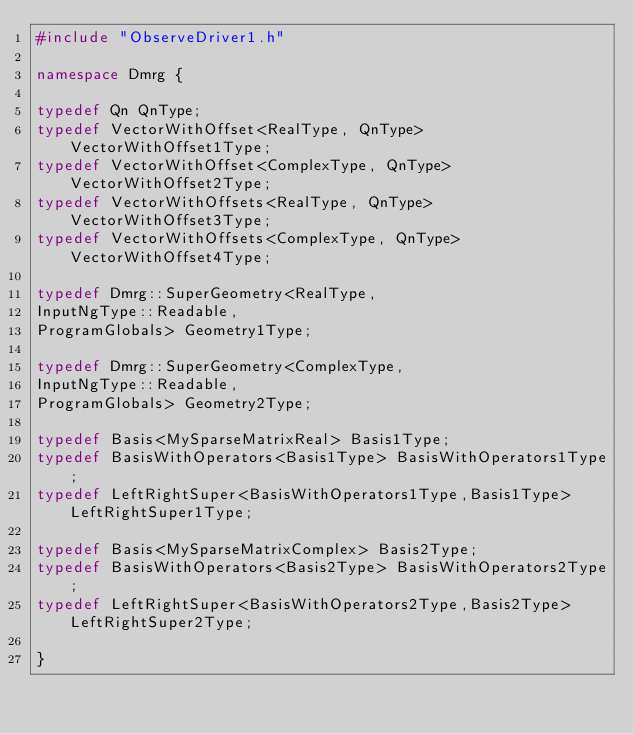Convert code to text. <code><loc_0><loc_0><loc_500><loc_500><_C++_>#include "ObserveDriver1.h"

namespace Dmrg {

typedef Qn QnType;
typedef VectorWithOffset<RealType, QnType> VectorWithOffset1Type;
typedef VectorWithOffset<ComplexType, QnType> VectorWithOffset2Type;
typedef VectorWithOffsets<RealType, QnType> VectorWithOffset3Type;
typedef VectorWithOffsets<ComplexType, QnType> VectorWithOffset4Type;

typedef Dmrg::SuperGeometry<RealType,
InputNgType::Readable,
ProgramGlobals> Geometry1Type;

typedef Dmrg::SuperGeometry<ComplexType,
InputNgType::Readable,
ProgramGlobals> Geometry2Type;

typedef Basis<MySparseMatrixReal> Basis1Type;
typedef BasisWithOperators<Basis1Type> BasisWithOperators1Type;
typedef LeftRightSuper<BasisWithOperators1Type,Basis1Type> LeftRightSuper1Type;

typedef Basis<MySparseMatrixComplex> Basis2Type;
typedef BasisWithOperators<Basis2Type> BasisWithOperators2Type;
typedef LeftRightSuper<BasisWithOperators2Type,Basis2Type> LeftRightSuper2Type;

}
</code> 